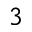Convert formula to latex. <formula><loc_0><loc_0><loc_500><loc_500>3</formula> 